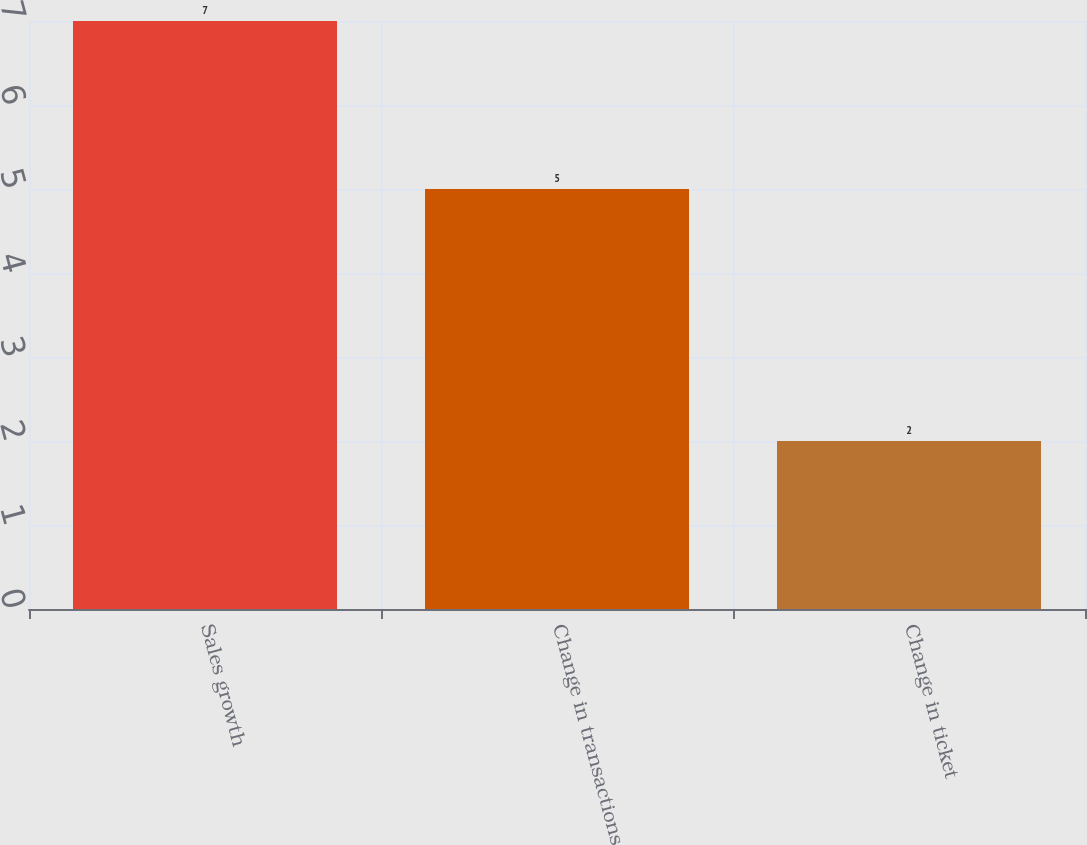Convert chart to OTSL. <chart><loc_0><loc_0><loc_500><loc_500><bar_chart><fcel>Sales growth<fcel>Change in transactions<fcel>Change in ticket<nl><fcel>7<fcel>5<fcel>2<nl></chart> 